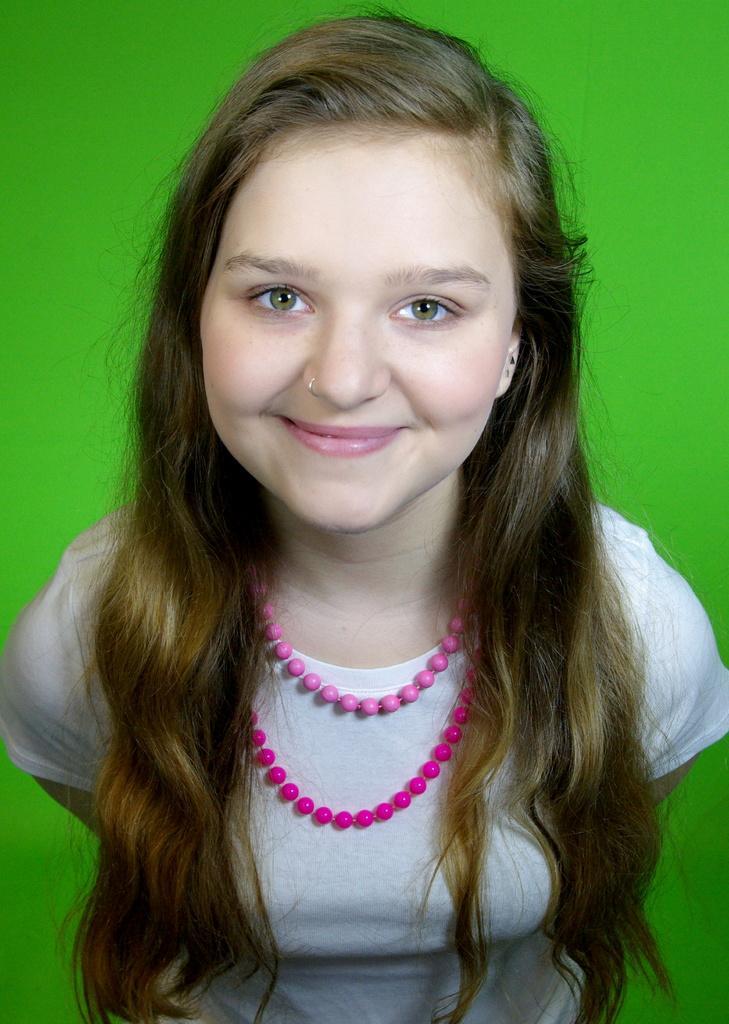Please provide a concise description of this image. In the foreground of this image, there is a woman wearing a pink color chain around her neck and there is a green background. 